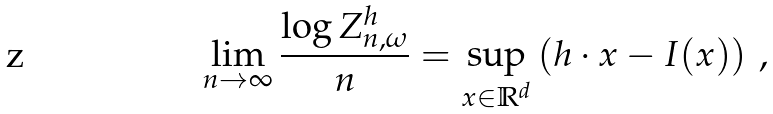Convert formula to latex. <formula><loc_0><loc_0><loc_500><loc_500>\lim _ { n \to \infty } \frac { \log Z ^ { h } _ { n , \omega } } { n } = \sup _ { x \in \mathbb { R } ^ { d } } \left ( h \cdot x - I ( x ) \right ) \, ,</formula> 